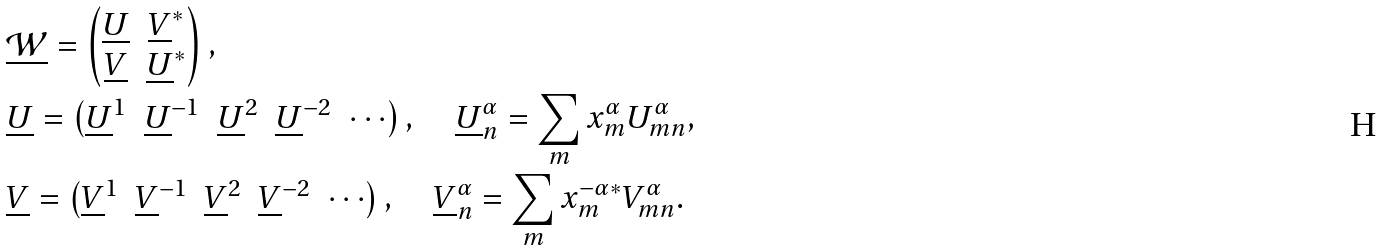Convert formula to latex. <formula><loc_0><loc_0><loc_500><loc_500>& \underline { \mathcal { W } } = \begin{pmatrix} \underline { U } & \underline { V } ^ { * } \\ \underline { V } & \underline { U } ^ { * } \end{pmatrix} , \\ & \underline { U } = \begin{pmatrix} \underline { U } ^ { 1 } & \underline { U } ^ { - 1 } & \underline { U } ^ { 2 } & \underline { U } ^ { - 2 } & \cdots \end{pmatrix} , \quad \underline { U } ^ { \alpha } _ { n } = \sum _ { m } x ^ { \alpha } _ { m } U ^ { \alpha } _ { m n } , \\ & \underline { V } = \begin{pmatrix} \underline { V } ^ { 1 } & \underline { V } ^ { - 1 } & \underline { V } ^ { 2 } & \underline { V } ^ { - 2 } & \cdots \end{pmatrix} , \quad \underline { V } ^ { \alpha } _ { n } = \sum _ { m } x ^ { - \alpha * } _ { m } V ^ { \alpha } _ { m n } .</formula> 